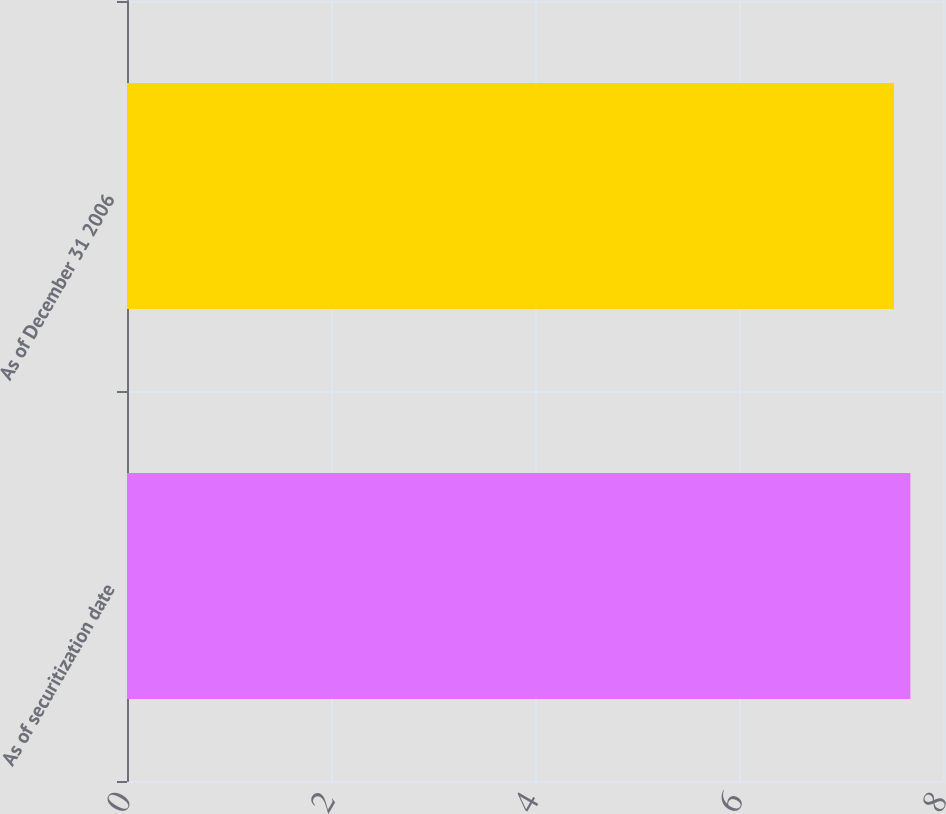<chart> <loc_0><loc_0><loc_500><loc_500><bar_chart><fcel>As of securitization date<fcel>As of December 31 2006<nl><fcel>7.68<fcel>7.52<nl></chart> 